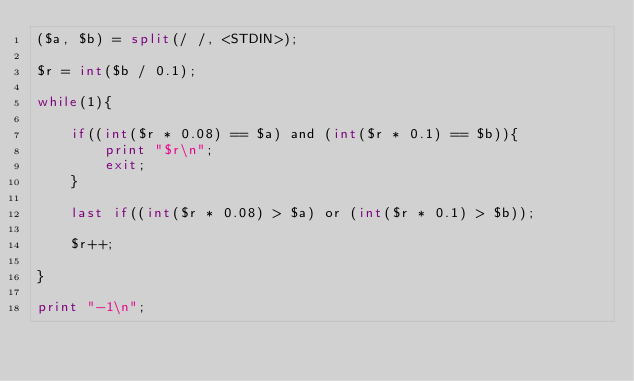Convert code to text. <code><loc_0><loc_0><loc_500><loc_500><_Perl_>($a, $b) = split(/ /, <STDIN>);

$r = int($b / 0.1);

while(1){

	if((int($r * 0.08) == $a) and (int($r * 0.1) == $b)){
		print "$r\n";
		exit;
	}

	last if((int($r * 0.08) > $a) or (int($r * 0.1) > $b));

	$r++;

}

print "-1\n";
</code> 